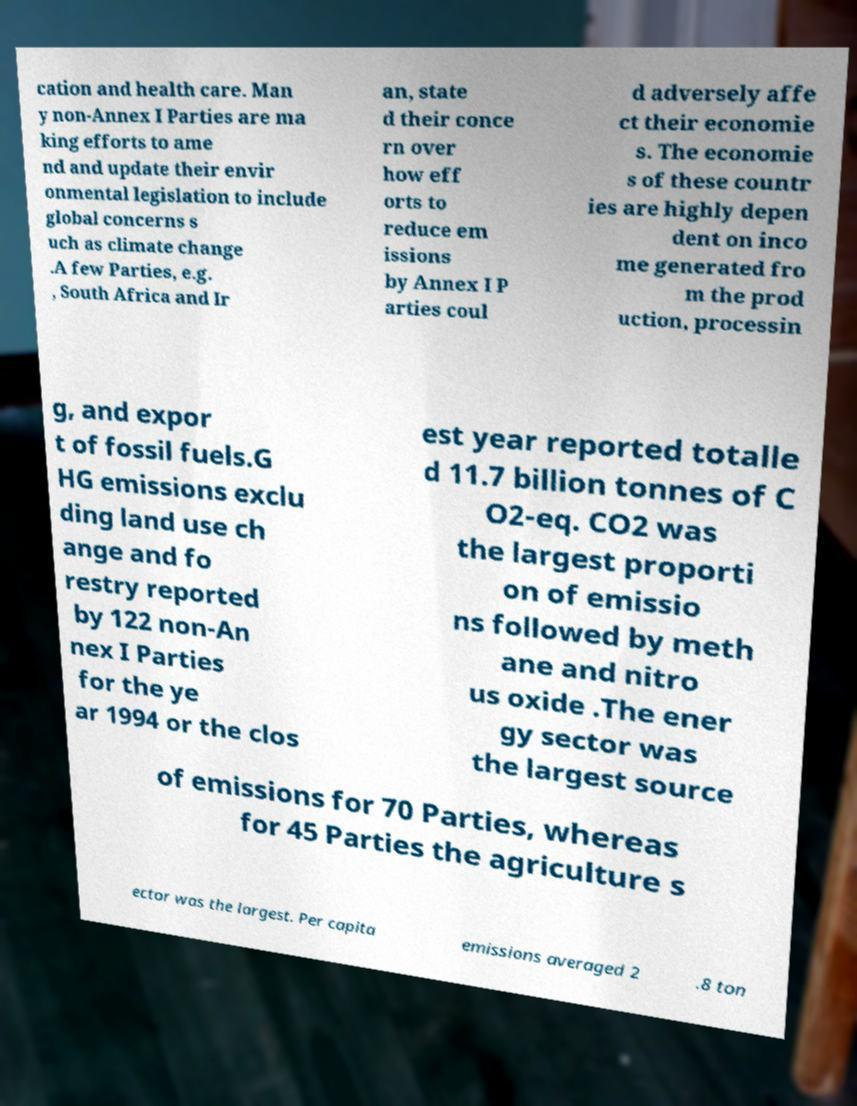Please identify and transcribe the text found in this image. cation and health care. Man y non-Annex I Parties are ma king efforts to ame nd and update their envir onmental legislation to include global concerns s uch as climate change .A few Parties, e.g. , South Africa and Ir an, state d their conce rn over how eff orts to reduce em issions by Annex I P arties coul d adversely affe ct their economie s. The economie s of these countr ies are highly depen dent on inco me generated fro m the prod uction, processin g, and expor t of fossil fuels.G HG emissions exclu ding land use ch ange and fo restry reported by 122 non-An nex I Parties for the ye ar 1994 or the clos est year reported totalle d 11.7 billion tonnes of C O2-eq. CO2 was the largest proporti on of emissio ns followed by meth ane and nitro us oxide .The ener gy sector was the largest source of emissions for 70 Parties, whereas for 45 Parties the agriculture s ector was the largest. Per capita emissions averaged 2 .8 ton 